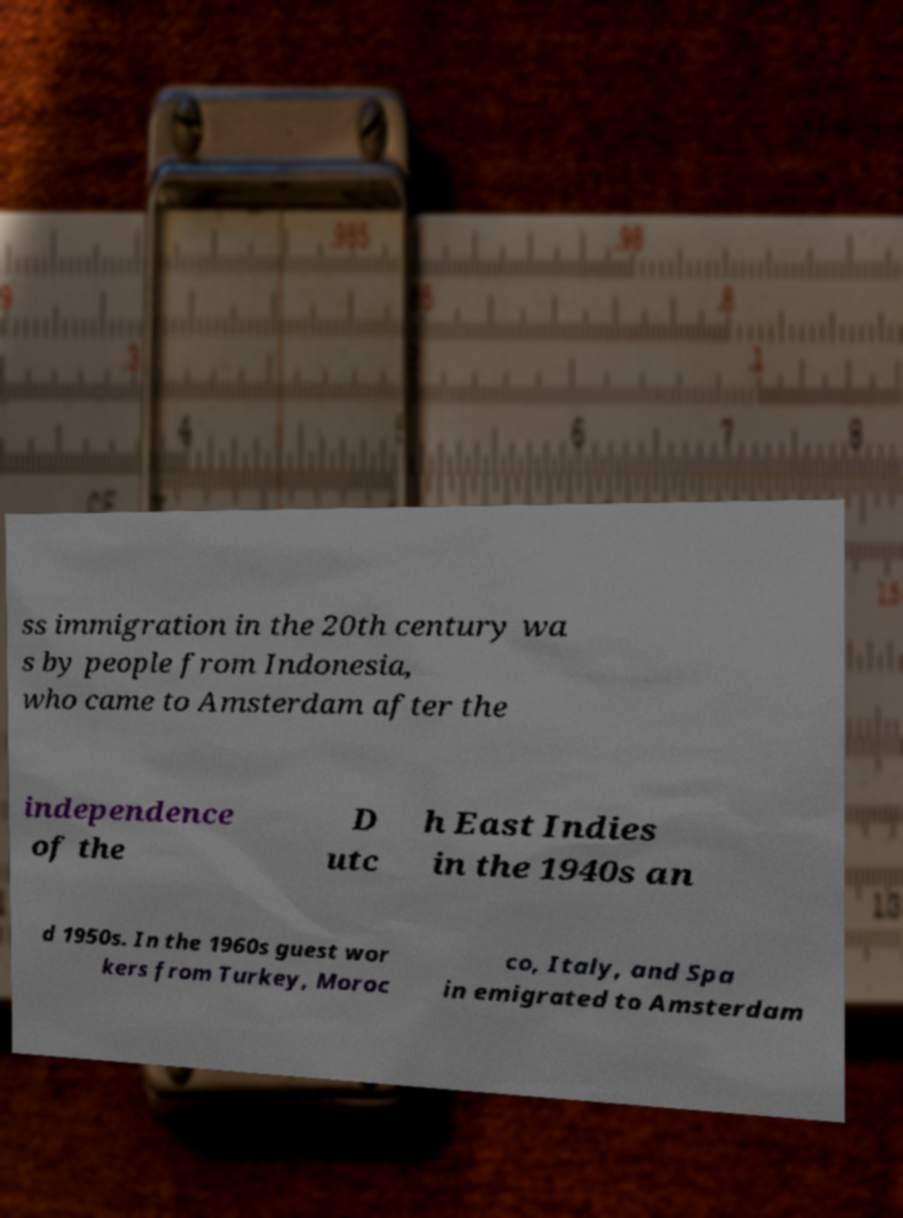There's text embedded in this image that I need extracted. Can you transcribe it verbatim? ss immigration in the 20th century wa s by people from Indonesia, who came to Amsterdam after the independence of the D utc h East Indies in the 1940s an d 1950s. In the 1960s guest wor kers from Turkey, Moroc co, Italy, and Spa in emigrated to Amsterdam 